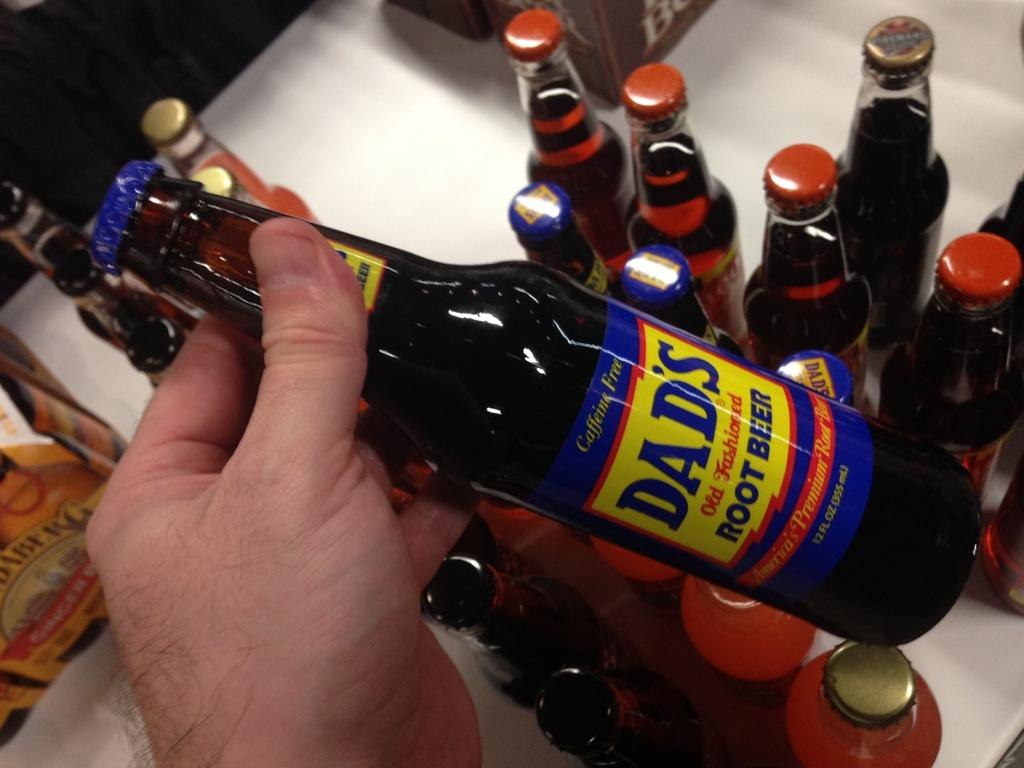<image>
Summarize the visual content of the image. A bottle, labelled Dad's old fashioned root beer, is being held. 